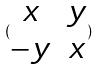Convert formula to latex. <formula><loc_0><loc_0><loc_500><loc_500>( \begin{matrix} x & y \\ - y & x \end{matrix} )</formula> 